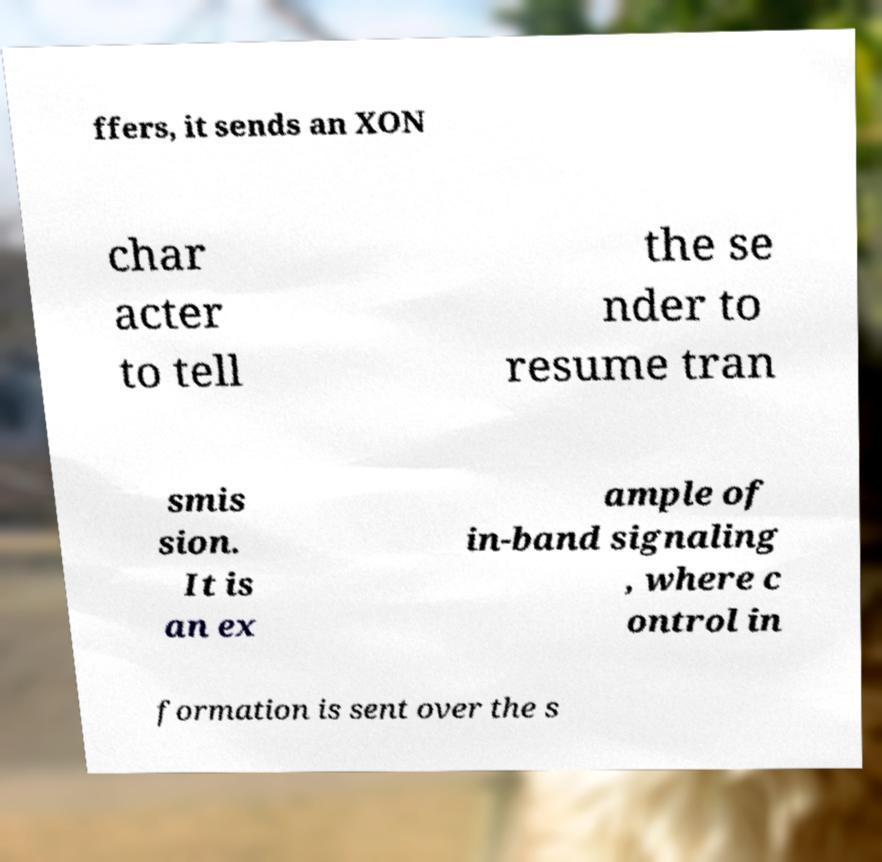Could you assist in decoding the text presented in this image and type it out clearly? ffers, it sends an XON char acter to tell the se nder to resume tran smis sion. It is an ex ample of in-band signaling , where c ontrol in formation is sent over the s 